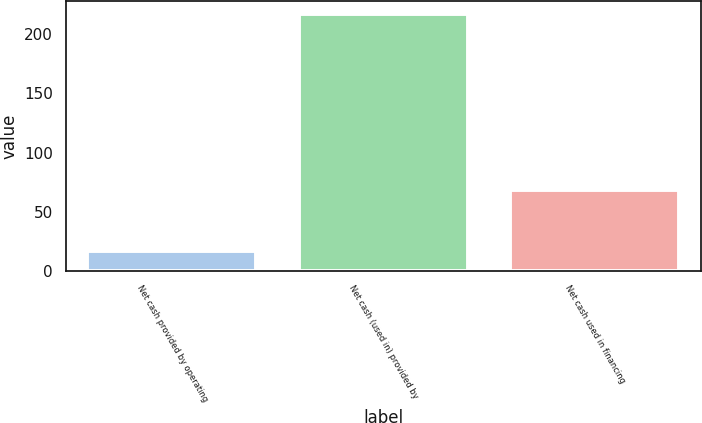<chart> <loc_0><loc_0><loc_500><loc_500><bar_chart><fcel>Net cash provided by operating<fcel>Net cash (used in) provided by<fcel>Net cash used in financing<nl><fcel>17<fcel>217<fcel>68<nl></chart> 